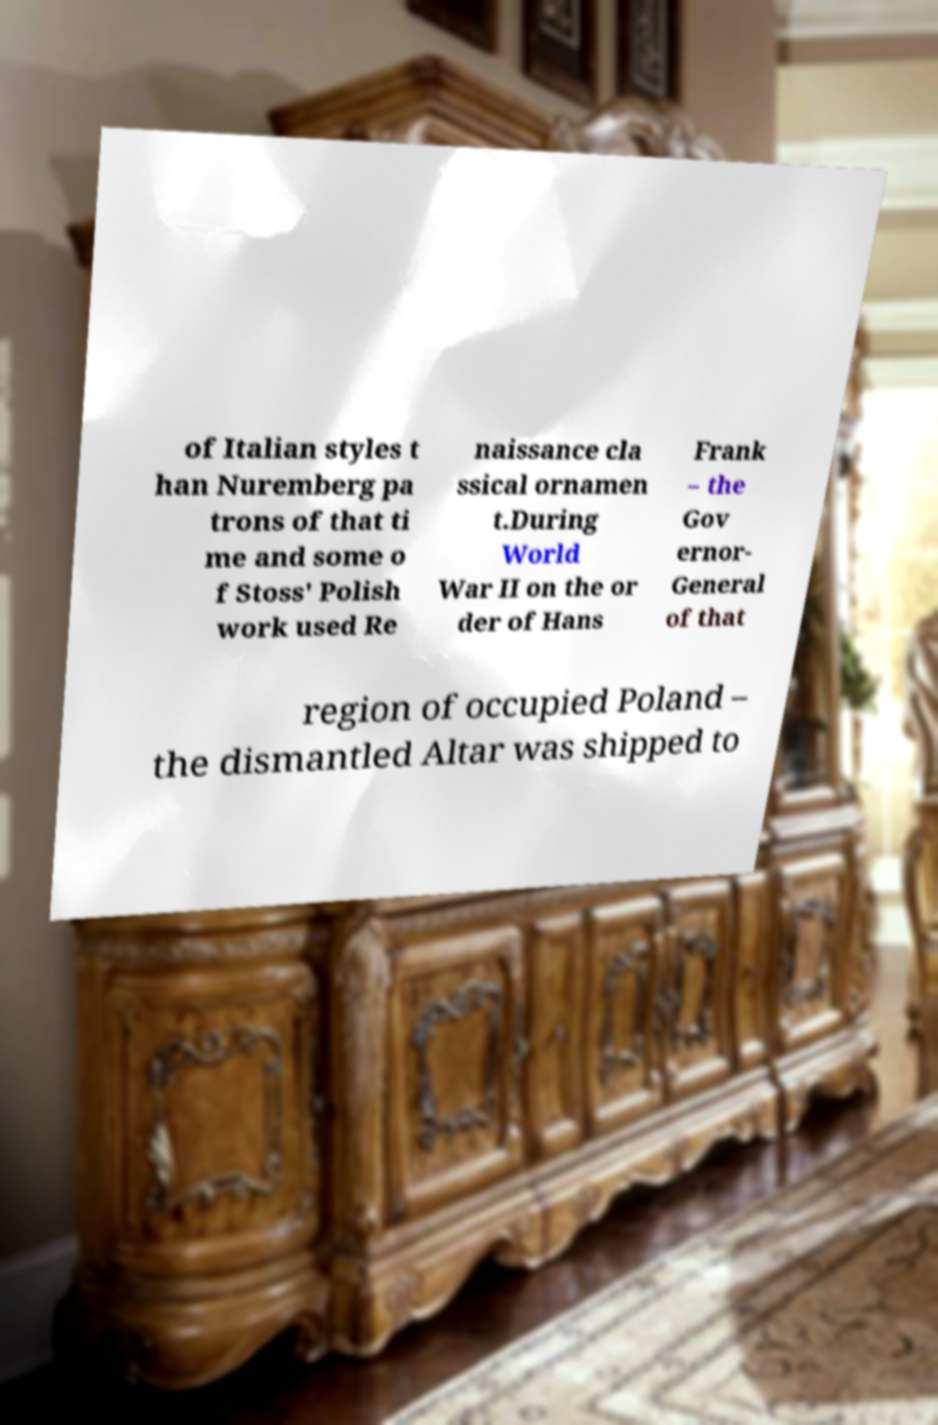Please read and relay the text visible in this image. What does it say? of Italian styles t han Nuremberg pa trons of that ti me and some o f Stoss' Polish work used Re naissance cla ssical ornamen t.During World War II on the or der of Hans Frank – the Gov ernor- General of that region of occupied Poland – the dismantled Altar was shipped to 